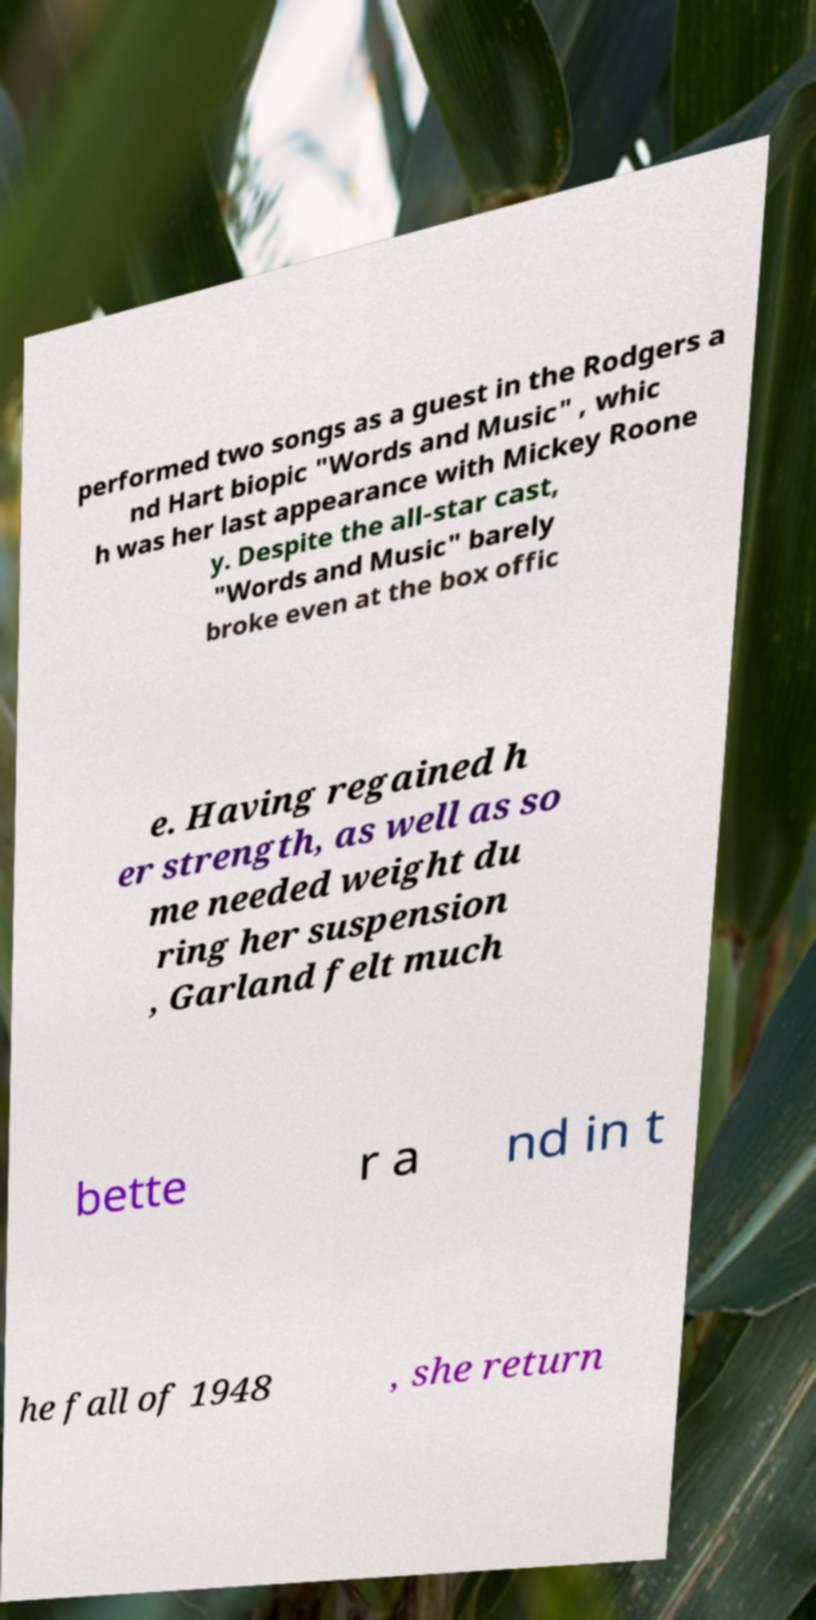What messages or text are displayed in this image? I need them in a readable, typed format. performed two songs as a guest in the Rodgers a nd Hart biopic "Words and Music" , whic h was her last appearance with Mickey Roone y. Despite the all-star cast, "Words and Music" barely broke even at the box offic e. Having regained h er strength, as well as so me needed weight du ring her suspension , Garland felt much bette r a nd in t he fall of 1948 , she return 